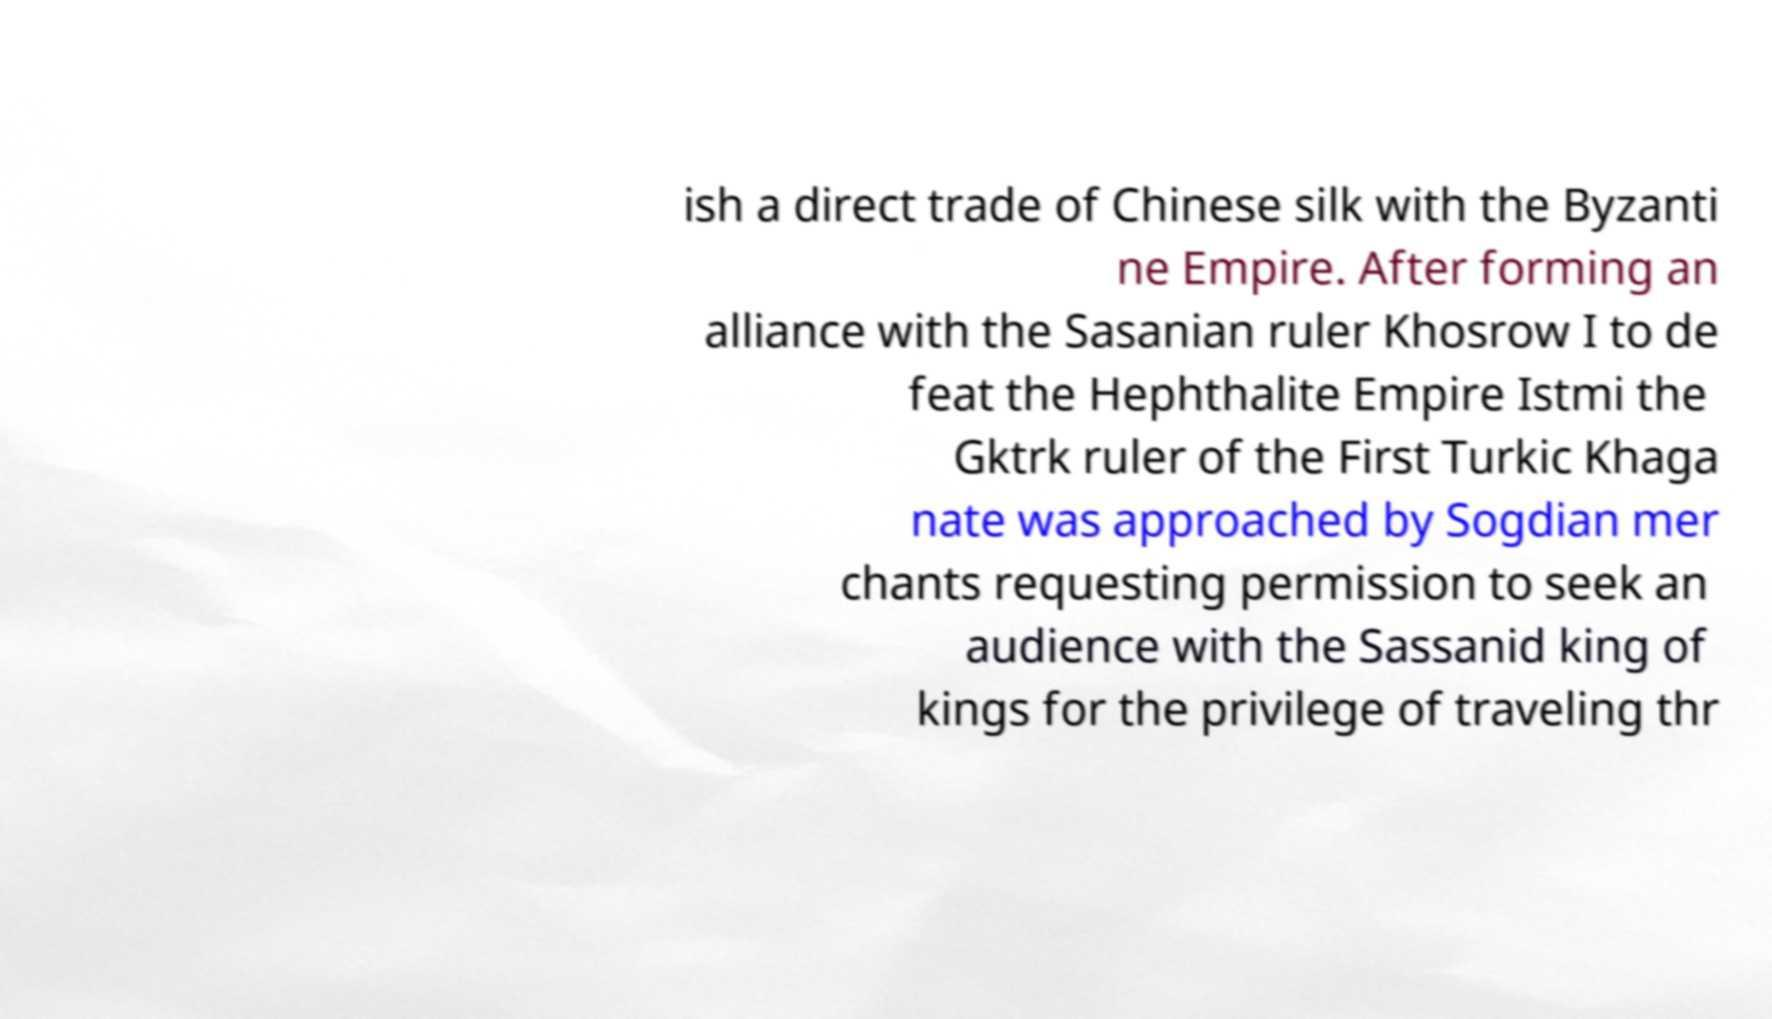Please identify and transcribe the text found in this image. ish a direct trade of Chinese silk with the Byzanti ne Empire. After forming an alliance with the Sasanian ruler Khosrow I to de feat the Hephthalite Empire Istmi the Gktrk ruler of the First Turkic Khaga nate was approached by Sogdian mer chants requesting permission to seek an audience with the Sassanid king of kings for the privilege of traveling thr 